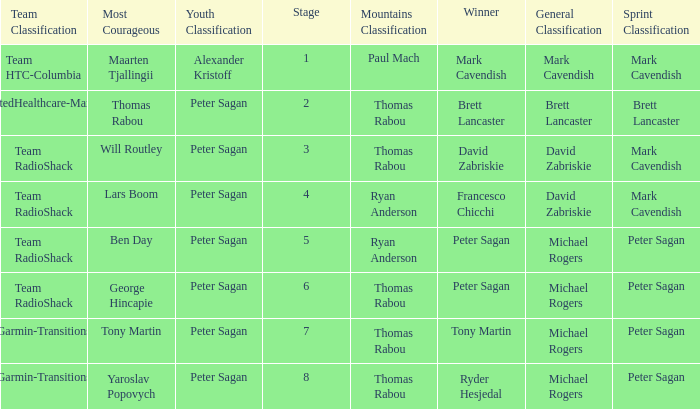When Peter Sagan won the youth classification and Thomas Rabou won the most corageous, who won the sprint classification? Brett Lancaster. 